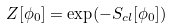Convert formula to latex. <formula><loc_0><loc_0><loc_500><loc_500>Z [ \phi _ { 0 } ] = \exp ( - S _ { c l } [ \phi _ { 0 } ] )</formula> 